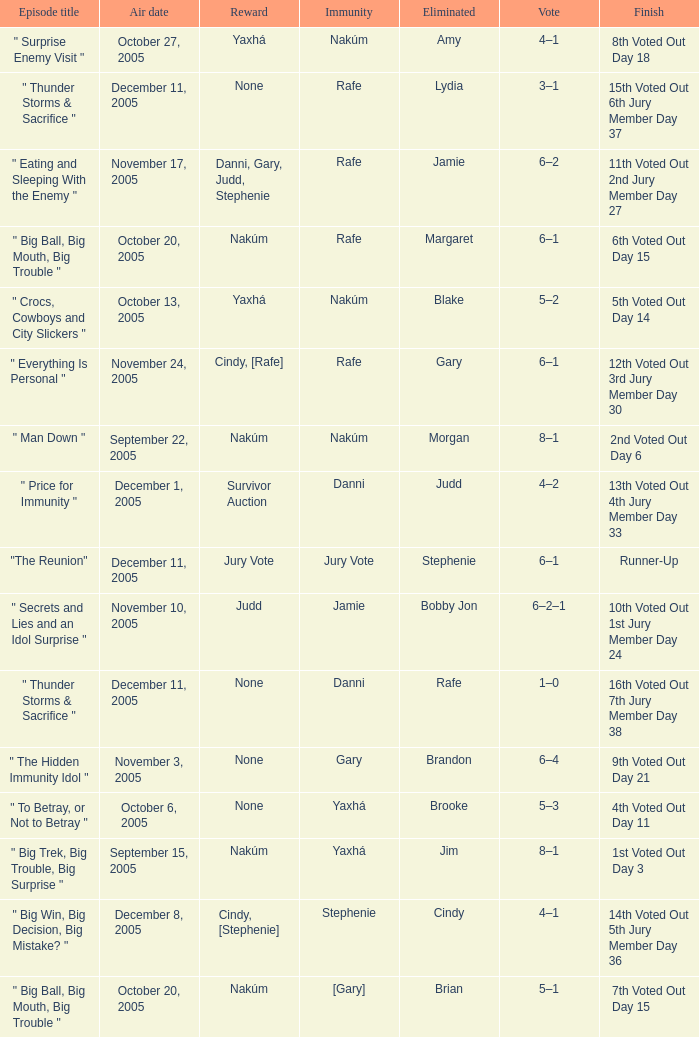When jim is eliminated what is the finish? 1st Voted Out Day 3. 